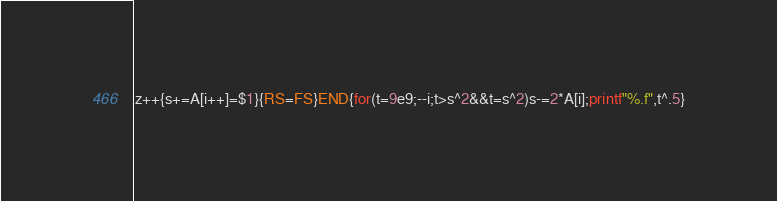<code> <loc_0><loc_0><loc_500><loc_500><_Awk_>z++{s+=A[i++]=$1}{RS=FS}END{for(t=9e9;--i;t>s^2&&t=s^2)s-=2*A[i];printf"%.f",t^.5}</code> 